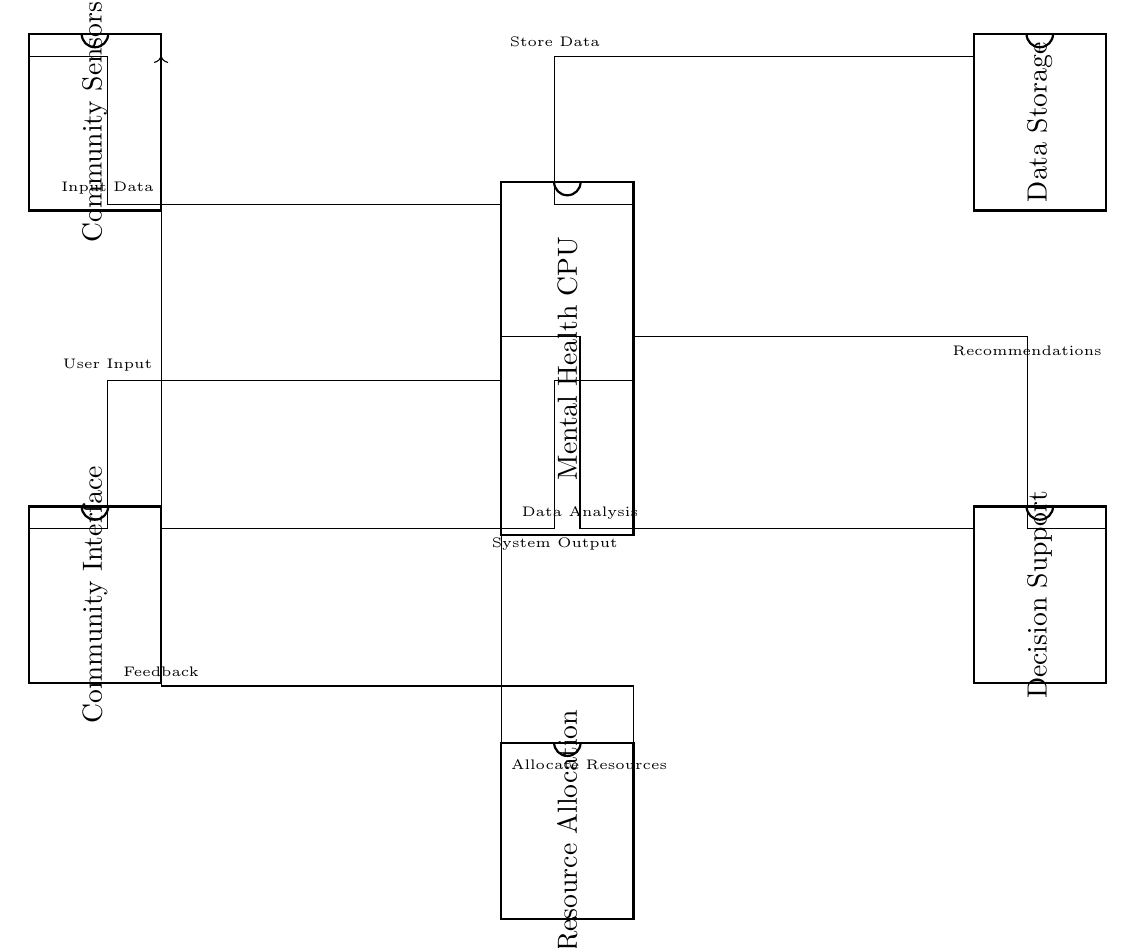What is the main processing unit in the circuit? The main processing unit is labeled as "Mental Health CPU," which processes inputs from community sensors and manages data storage and resource allocation.
Answer: Mental Health CPU How many pins does the Community Sensors component have? The Community Sensors component is depicted as a dip chip with 8 pins, indicating its connection points for inputs and outputs.
Answer: 8 What kind of feedback does the circuit provide? The circuit includes a feedback loop from the Resource Allocation unit to the Community Sensors, which suggests that the system can adjust based on allocated resources and their effectiveness.
Answer: Feedback What is the first data flow connection in the circuit? The first data flow connection is from the Community Sensors to the Mental Health CPU, indicating that the data input is collected from the community sensors for processing.
Answer: Input Data Which unit receives data for analysis? The Decision Support unit receives data for analysis from the Mental Health CPU, allowing it to assess the inputs and contribute to recommendations for resource allocation.
Answer: Data Analysis What is the output of the Mental Health CPU? The output from the Mental Health CPU is directed to the Community Interface which provides system output back to the community users.
Answer: System Output 